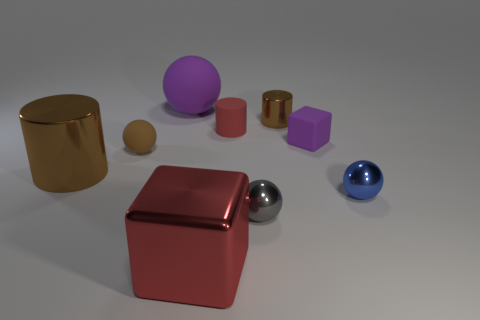There is a tiny thing that is the same color as the big sphere; what shape is it?
Your answer should be very brief. Cube. Is there any other thing that has the same color as the tiny block?
Provide a succinct answer. Yes. How many purple blocks are there?
Give a very brief answer. 1. There is a small blue thing that is the same shape as the gray thing; what is its material?
Provide a succinct answer. Metal. Do the brown thing that is behind the red matte cylinder and the big red thing have the same material?
Your response must be concise. Yes. Is the number of tiny red cylinders on the left side of the big matte object greater than the number of purple rubber things on the left side of the small brown sphere?
Your answer should be compact. No. What is the size of the matte cube?
Your response must be concise. Small. What is the shape of the small gray thing that is the same material as the tiny blue sphere?
Provide a succinct answer. Sphere. Is the shape of the large object that is in front of the small blue sphere the same as  the large brown metal thing?
Your answer should be compact. No. What number of things are either large yellow shiny objects or matte objects?
Offer a terse response. 4. 